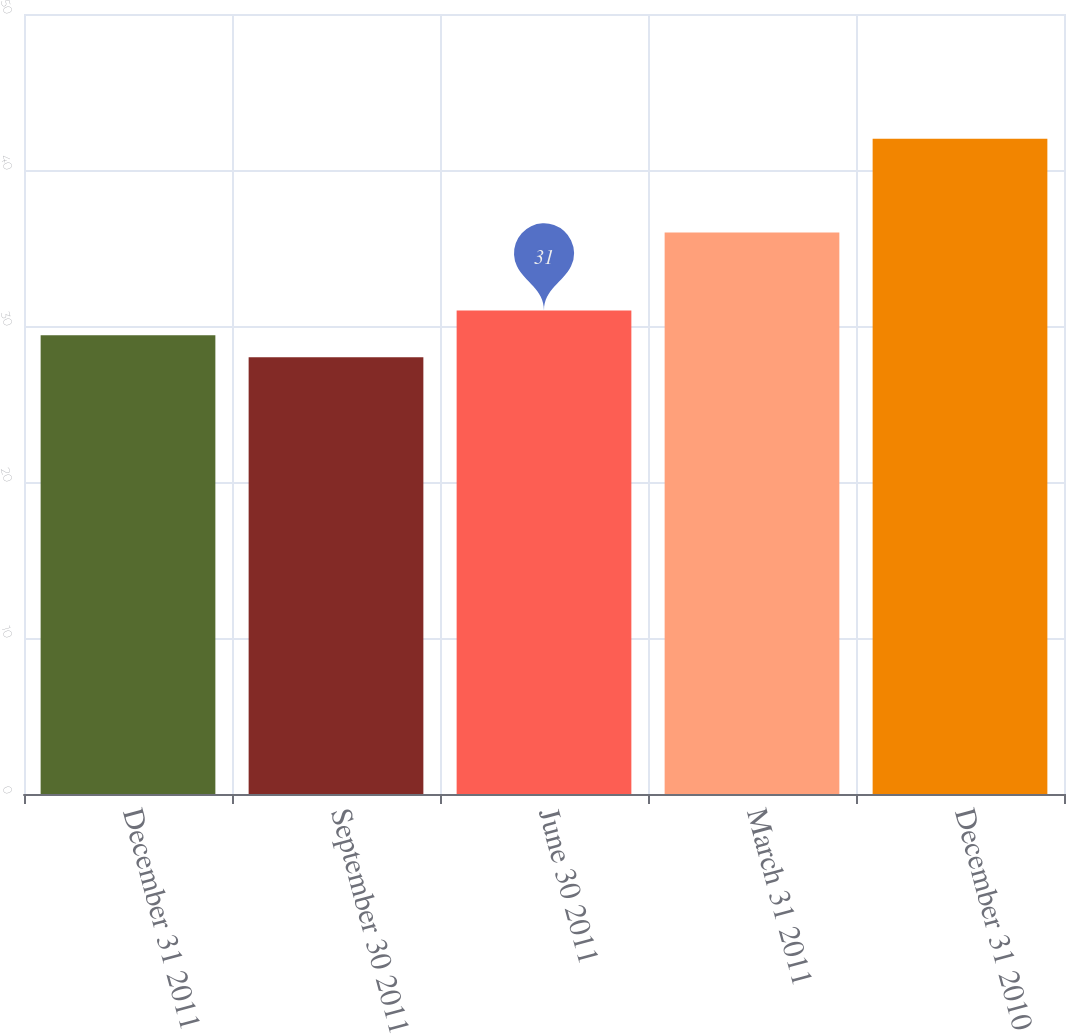<chart> <loc_0><loc_0><loc_500><loc_500><bar_chart><fcel>December 31 2011<fcel>September 30 2011<fcel>June 30 2011<fcel>March 31 2011<fcel>December 31 2010<nl><fcel>29.4<fcel>28<fcel>31<fcel>36<fcel>42<nl></chart> 